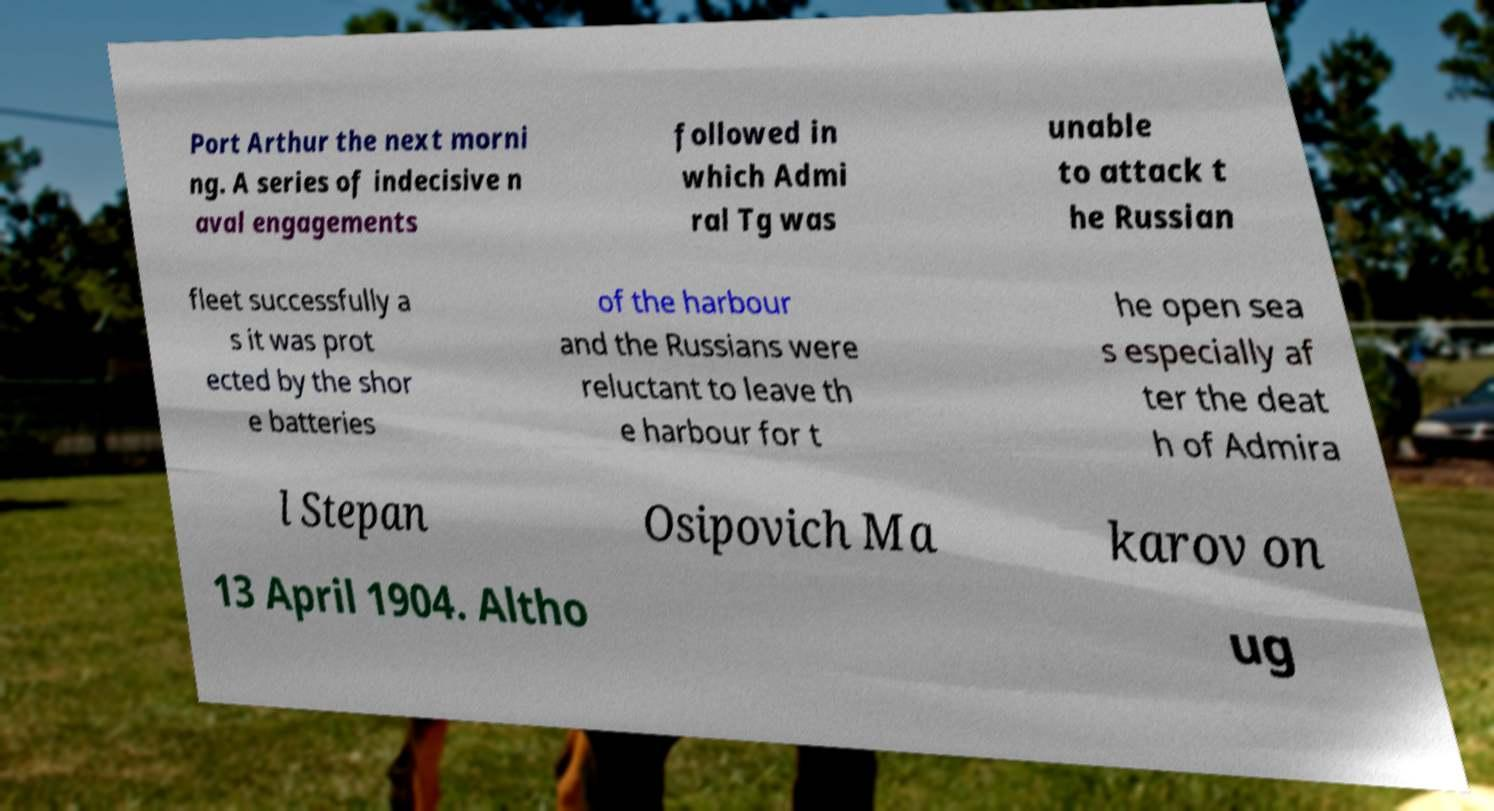Could you extract and type out the text from this image? Port Arthur the next morni ng. A series of indecisive n aval engagements followed in which Admi ral Tg was unable to attack t he Russian fleet successfully a s it was prot ected by the shor e batteries of the harbour and the Russians were reluctant to leave th e harbour for t he open sea s especially af ter the deat h of Admira l Stepan Osipovich Ma karov on 13 April 1904. Altho ug 